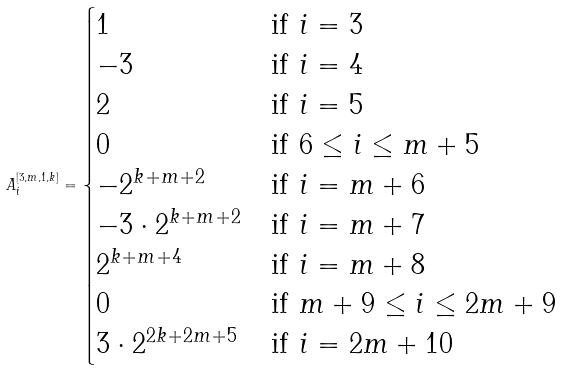<formula> <loc_0><loc_0><loc_500><loc_500>A _ { i } ^ { [ 3 , m , 1 , k ] } = \begin{cases} 1 & \text {if } i = 3 \\ - 3 & \text {if } i = 4 \\ 2 & \text {if } i = 5 \\ 0 & \text {if } 6 \leq i \leq m + 5 \\ - 2 ^ { k + m + 2 } & \text {if } i = m + 6 \\ - 3 \cdot 2 ^ { k + m + 2 } & \text {if } i = m + 7 \\ 2 ^ { k + m + 4 } & \text {if } i = m + 8 \\ 0 & \text {if } m + 9 \leq i \leq 2 m + 9 \\ 3 \cdot 2 ^ { 2 k + 2 m + 5 } & \text {if } i = 2 m + 1 0 \end{cases}</formula> 